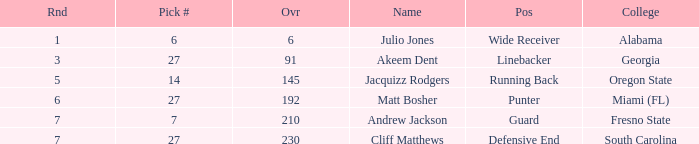Which overall's pick number was 14? 145.0. 